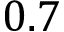<formula> <loc_0><loc_0><loc_500><loc_500>0 . 7</formula> 